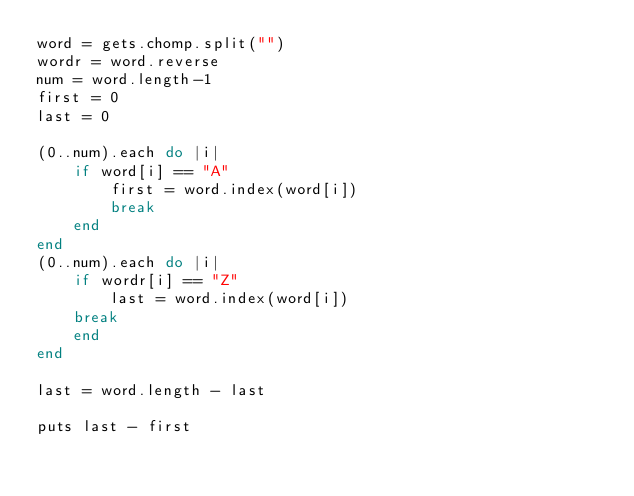<code> <loc_0><loc_0><loc_500><loc_500><_Ruby_>word = gets.chomp.split("")
wordr = word.reverse
num = word.length-1
first = 0
last = 0

(0..num).each do |i|
    if word[i] == "A"
        first = word.index(word[i])
        break
    end
end
(0..num).each do |i|
    if wordr[i] == "Z"
        last = word.index(word[i])
    break
    end
end

last = word.length - last

puts last - first</code> 